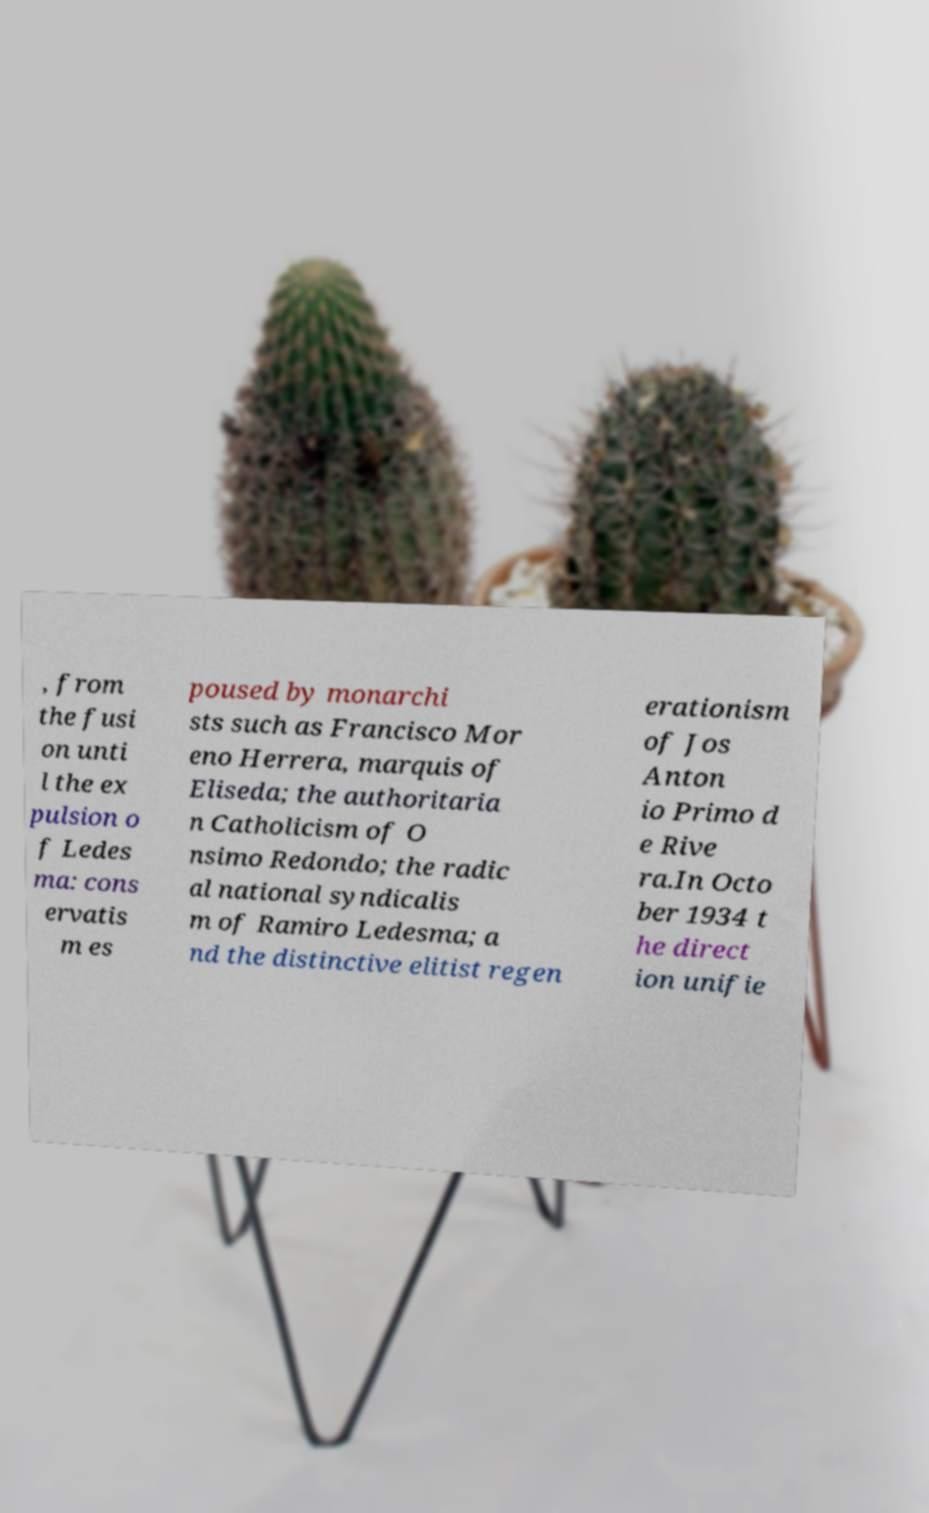There's text embedded in this image that I need extracted. Can you transcribe it verbatim? , from the fusi on unti l the ex pulsion o f Ledes ma: cons ervatis m es poused by monarchi sts such as Francisco Mor eno Herrera, marquis of Eliseda; the authoritaria n Catholicism of O nsimo Redondo; the radic al national syndicalis m of Ramiro Ledesma; a nd the distinctive elitist regen erationism of Jos Anton io Primo d e Rive ra.In Octo ber 1934 t he direct ion unifie 